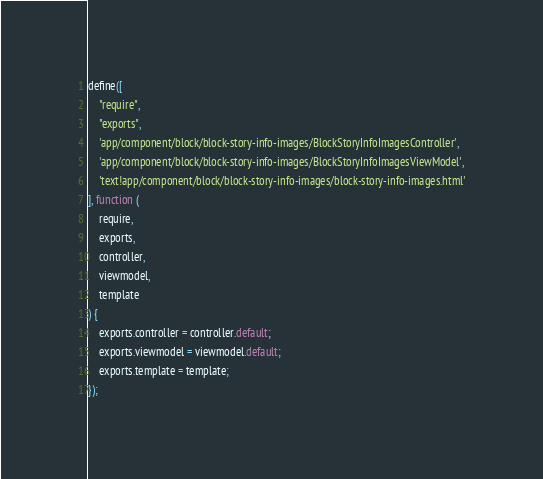Convert code to text. <code><loc_0><loc_0><loc_500><loc_500><_JavaScript_>define([
    "require",
    "exports",
    'app/component/block/block-story-info-images/BlockStoryInfoImagesController',
    'app/component/block/block-story-info-images/BlockStoryInfoImagesViewModel',
    'text!app/component/block/block-story-info-images/block-story-info-images.html'
], function (
    require,
    exports,
    controller,
    viewmodel,
    template
) {
    exports.controller = controller.default;
    exports.viewmodel = viewmodel.default;
    exports.template = template;
});
</code> 